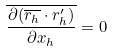Convert formula to latex. <formula><loc_0><loc_0><loc_500><loc_500>\overline { \frac { \partial ( \overline { r _ { h } } \cdot r _ { h } ^ { \prime } ) } { \partial x _ { h } } } = 0</formula> 